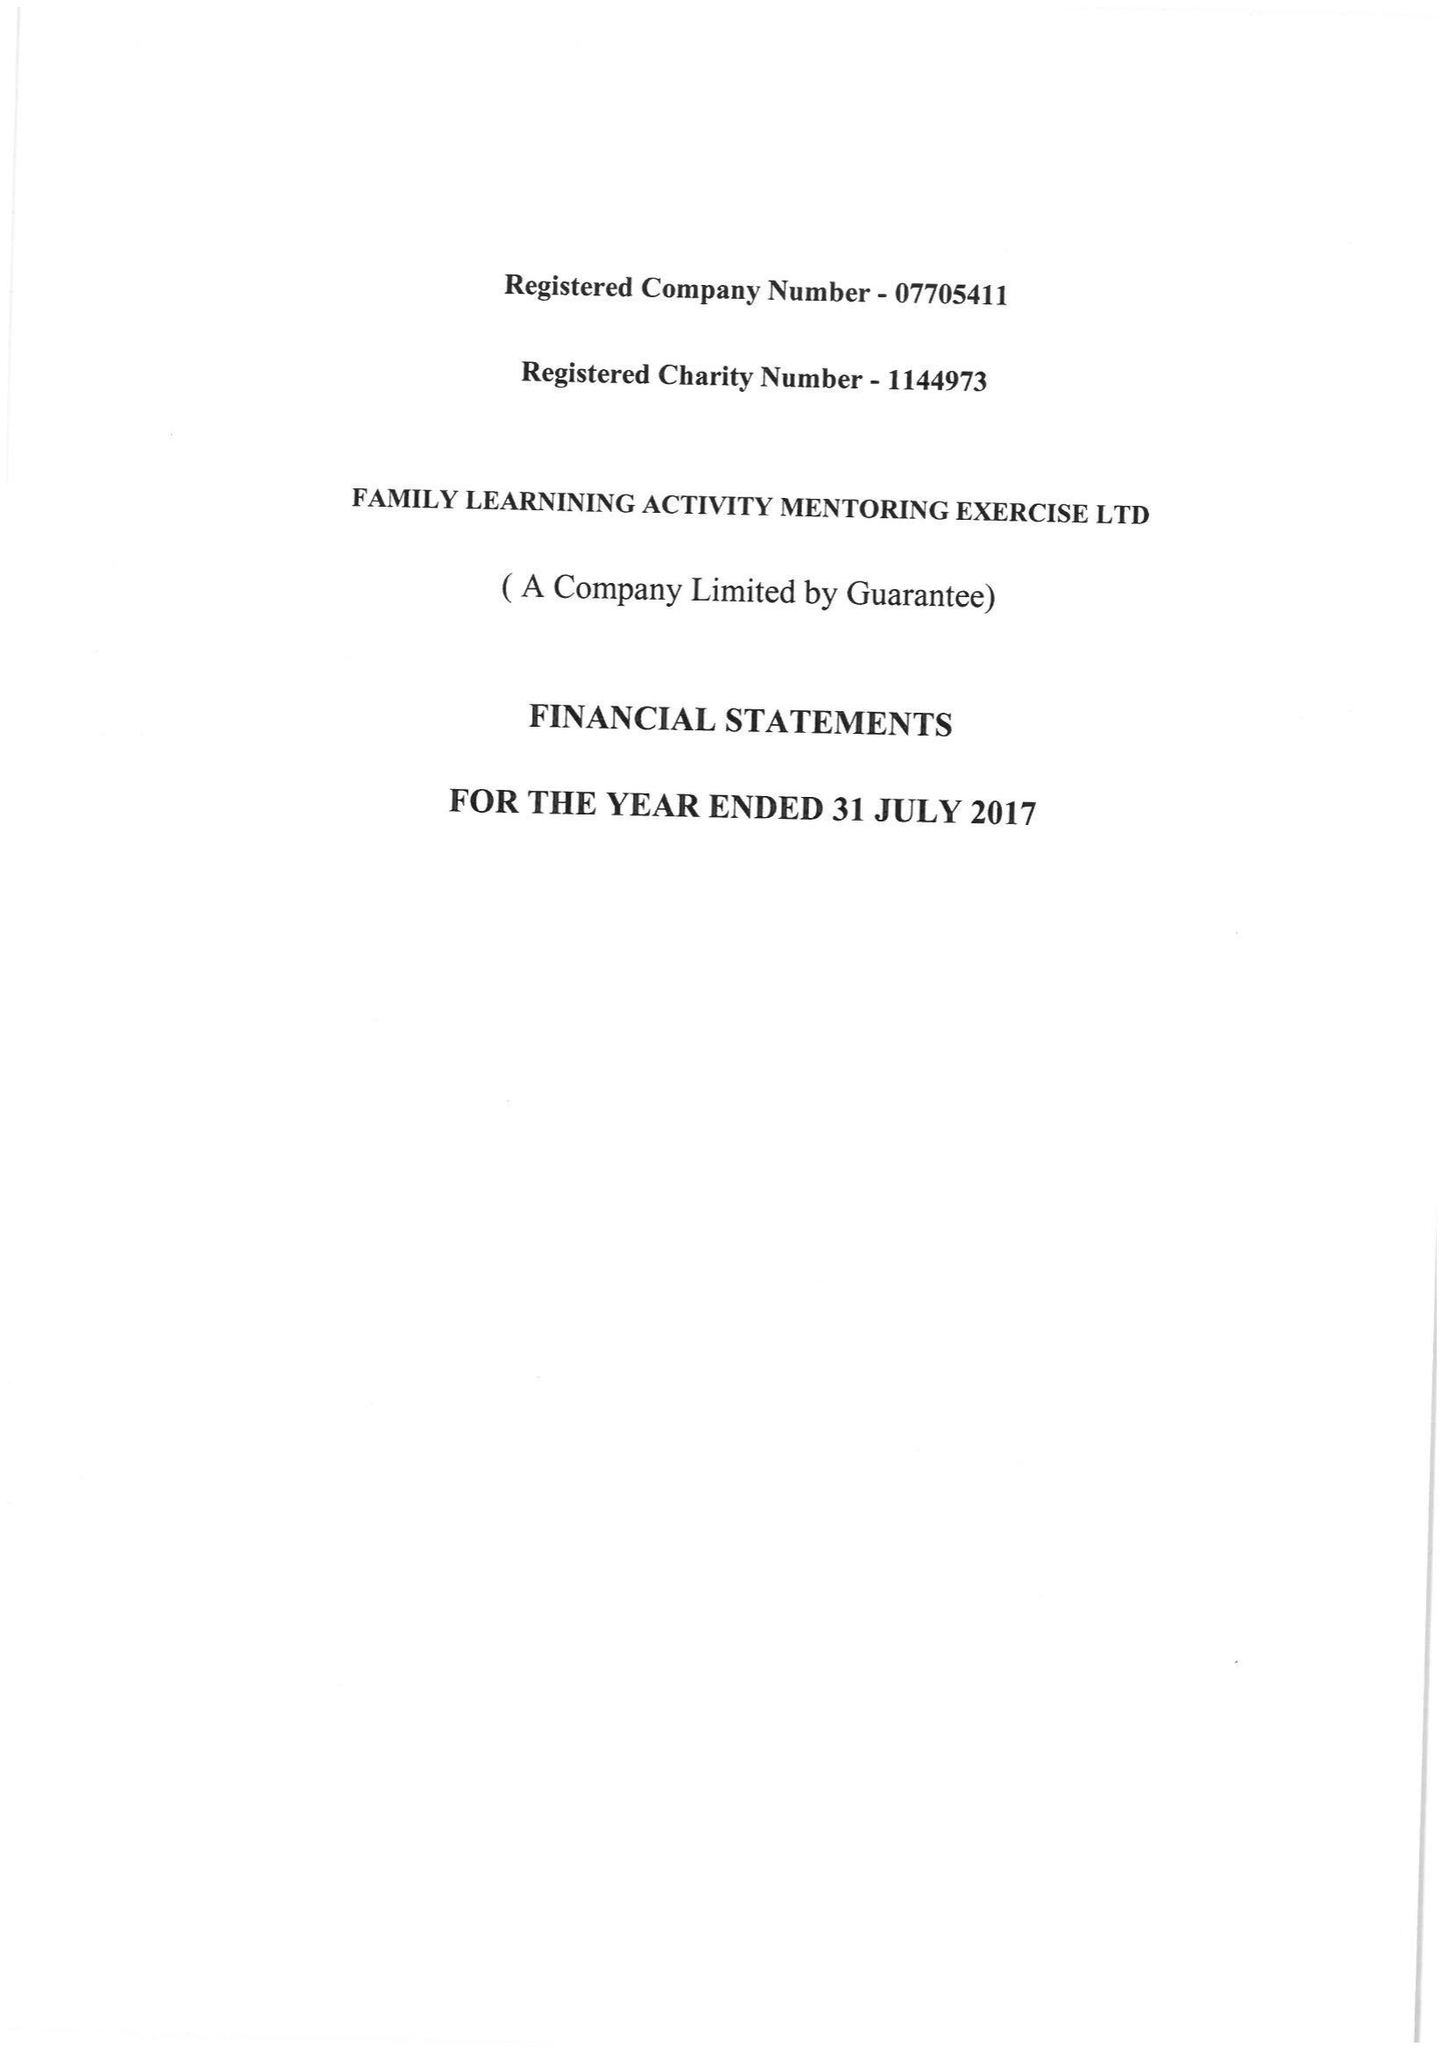What is the value for the report_date?
Answer the question using a single word or phrase. 2017-07-31 